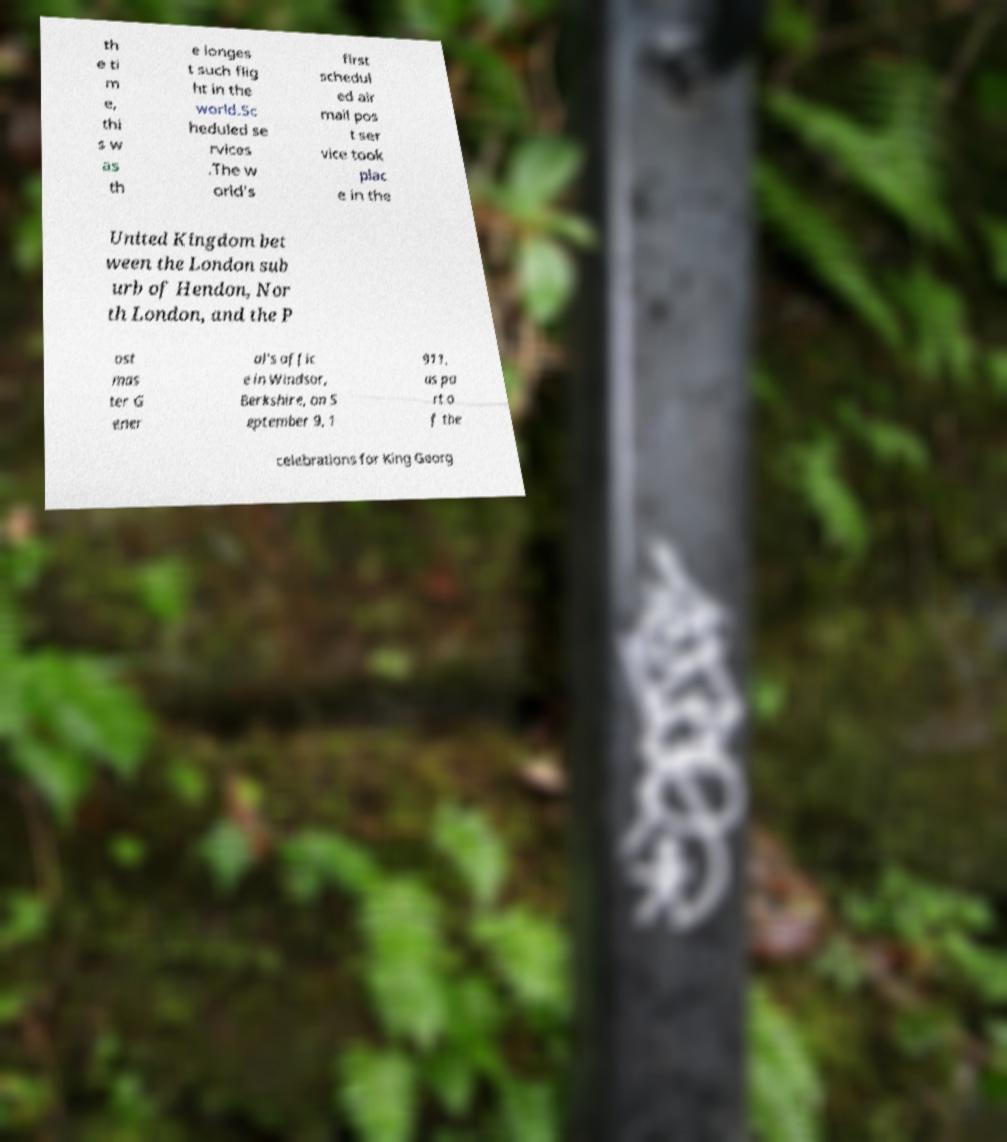Please read and relay the text visible in this image. What does it say? th e ti m e, thi s w as th e longes t such flig ht in the world.Sc heduled se rvices .The w orld's first schedul ed air mail pos t ser vice took plac e in the United Kingdom bet ween the London sub urb of Hendon, Nor th London, and the P ost mas ter G ener al's offic e in Windsor, Berkshire, on S eptember 9, 1 911, as pa rt o f the celebrations for King Georg 